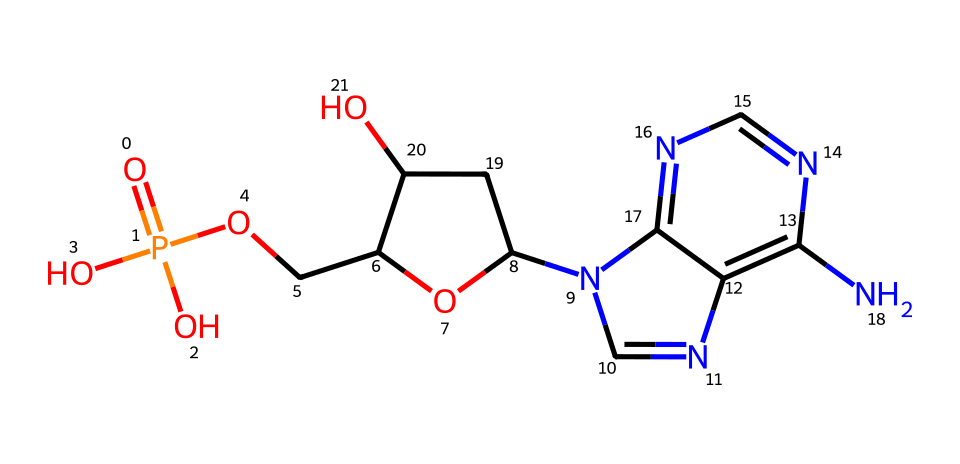What type of molecule is represented by this SMILES? The SMILES notation indicates the presence of a phosphate group and a sugar moiety along with nitrogen-containing bases. These features classify it as a nucleotide, which is the building block of nucleic acids like DNA and RNA.
Answer: nucleotide How many nitrogen atoms are present in the structure? By examining the SMILES string, there are two instances of 'N' which indicate the presence of nitrogen atoms. A close look at the chemical structure confirms there are two nitrogen atoms in the ring structure.
Answer: two What is the role of the phosphate group in this nucleotide? The phosphate group (O=P(O)(O)O) connects to the sugar and contributes to the backbone of nucleic acids, facilitating the connection between nucleotides through phosphodiester bonds.
Answer: backbone What type of sugar is present in this nucleotide? The sugar moiety in this nucleotide consists of a ribofuranose structure, which can be inferred from the presence of the 'O' atoms and the cyclic form (indicated by 'C1OCC') in the SMILES.
Answer: ribose How many carbon atoms are in the sugar part of this nucleotide? Counting the carbon atoms in the sugar part (C1OC), there are five carbon atoms typically found in ribose, fitting the general structure for ribonucleotides.
Answer: five What is the significance of the nitrogen-containing base in this structure? The nitrogen-containing base, which is part of the bicyclic structure, is essential for base pairing in DNA and RNA, determining the genetic information coded within.
Answer: genetic information 